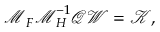Convert formula to latex. <formula><loc_0><loc_0><loc_500><loc_500>\mathcal { M } _ { F } \mathcal { M } _ { H } ^ { - 1 } \mathcal { Q } \mathcal { W } = \mathcal { K } ,</formula> 